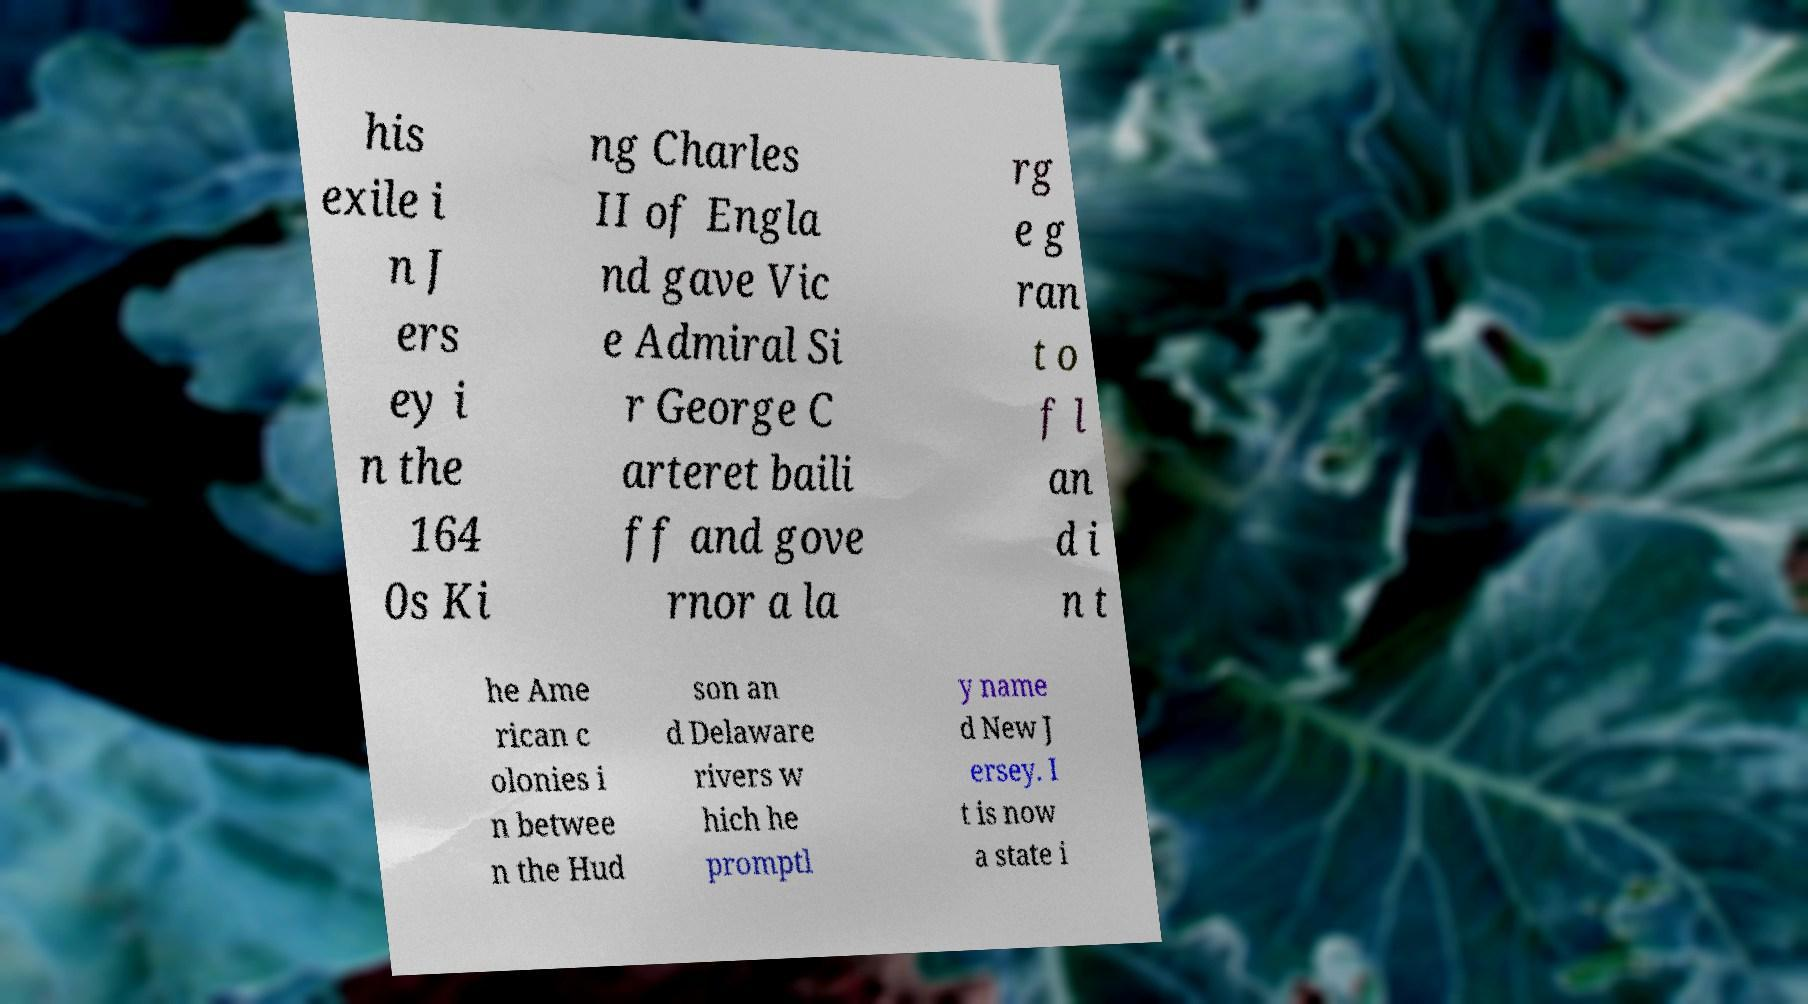Can you read and provide the text displayed in the image?This photo seems to have some interesting text. Can you extract and type it out for me? his exile i n J ers ey i n the 164 0s Ki ng Charles II of Engla nd gave Vic e Admiral Si r George C arteret baili ff and gove rnor a la rg e g ran t o f l an d i n t he Ame rican c olonies i n betwee n the Hud son an d Delaware rivers w hich he promptl y name d New J ersey. I t is now a state i 